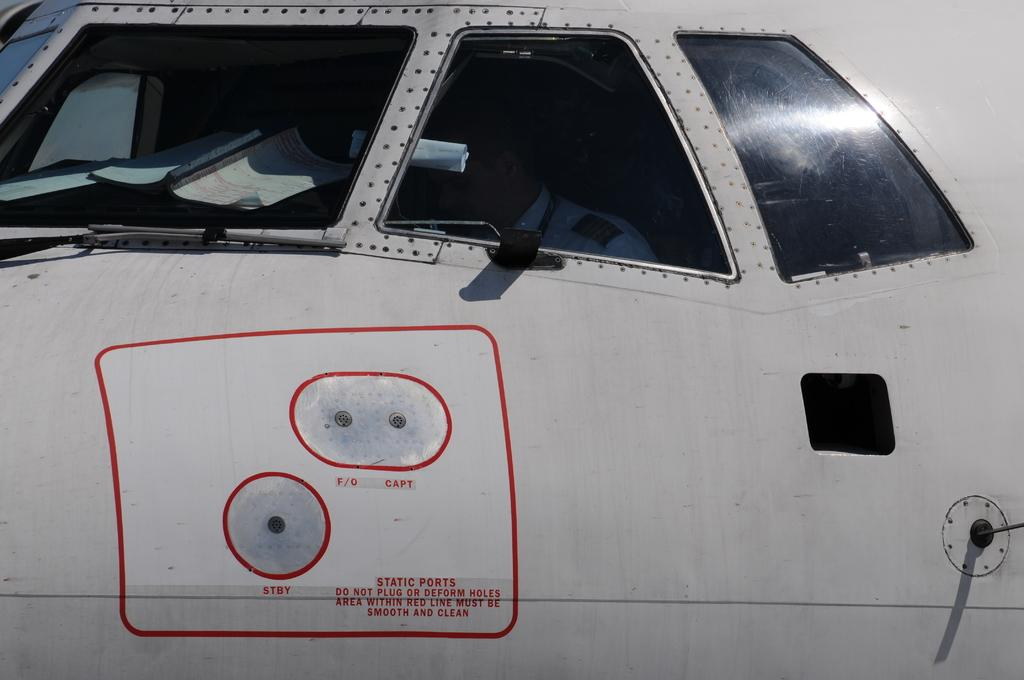What is the main subject of the zoomed-in picture? The main subject of the zoomed-in picture is an aeroplane. What can be seen on the aeroplane? There is text visible on the aeroplane. What other object is present in the image? There is a book in the image. Can you tell if there is anyone inside the aeroplane? Yes, there is a person inside the aeroplane. What type of map can be seen on the person's suit in the image? There is no map or suit present in the image; it only features an aeroplane with text, a book, and a person inside. 